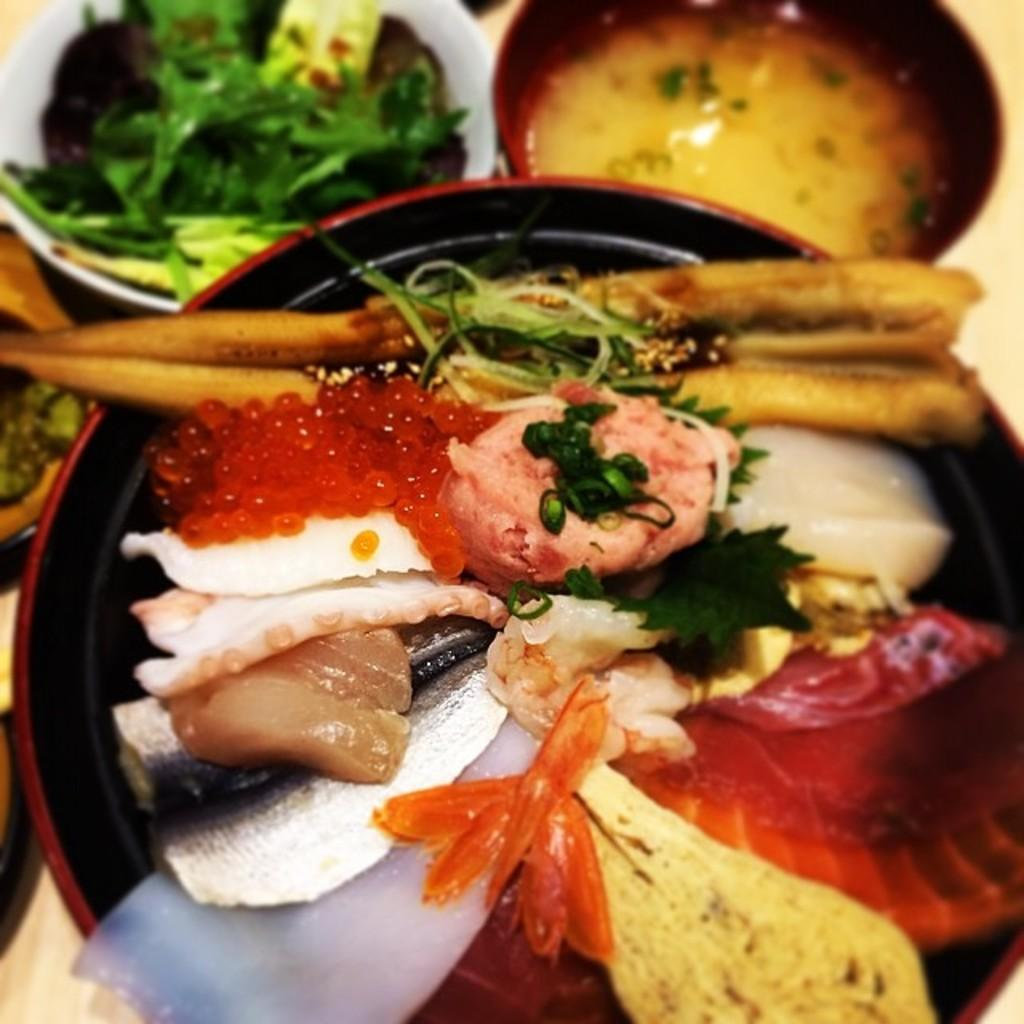What type of objects can be seen in the image? There are bowls and food in the image. What colors are the bowls? The bowls are in white, red, and black colors. How would you describe the food? The food is colorful. What is the color of the surface where the bowls and food are placed? The food and bowls are on a cream-colored surface. What type of border is present around the food in the image? There is no border present around the food in the image. Can you see a rod holding the bowls in the image? There is no rod holding the bowls in the image. 